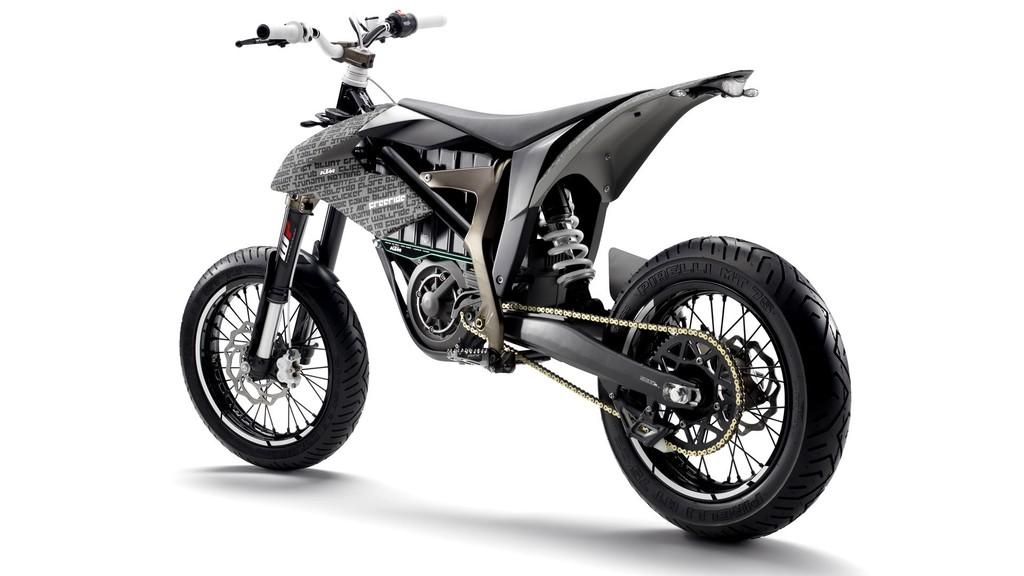What type of vehicle is in the image? There is a bicycle in the image. What feature of the bicycle is mentioned in the facts? The bicycle has strong wheels. How does the bicycle compare to other types of vehicles? The bicycle appears to be similar to a two-wheeler scooter. What color is the army paint on the bicycle in the image? There is no mention of an army or paint in the image, so it is not possible to answer that question. 